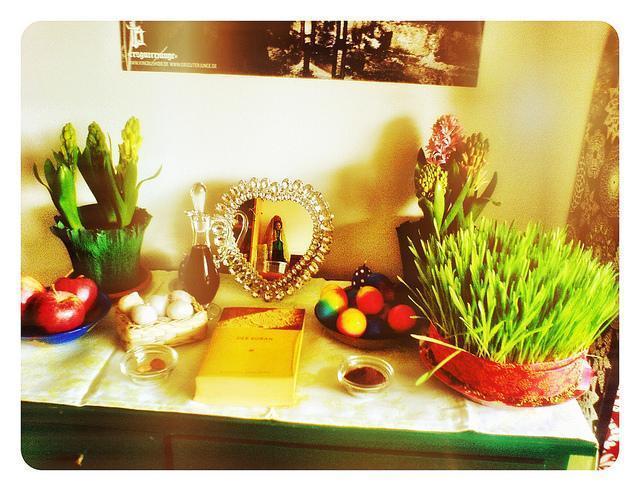How many potted plants are there?
Give a very brief answer. 3. 